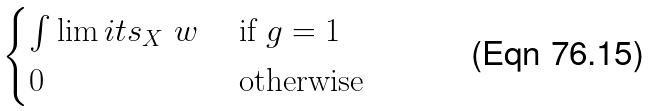Convert formula to latex. <formula><loc_0><loc_0><loc_500><loc_500>\begin{cases} \int \lim i t s _ { X } \ w & \text { if } g = 1 \\ 0 & \text { otherwise} \end{cases}</formula> 